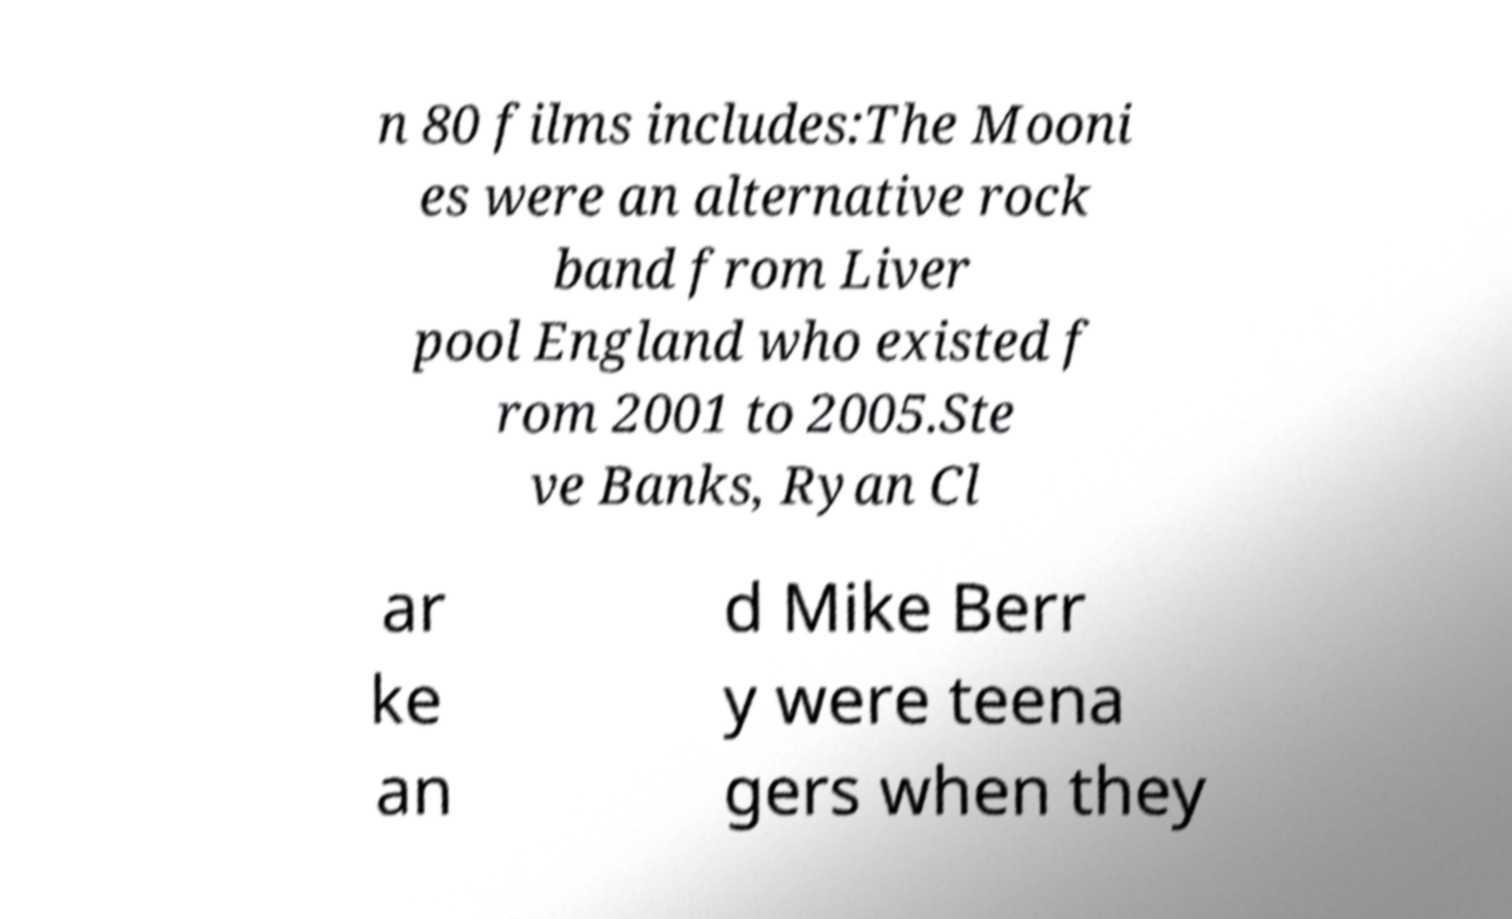There's text embedded in this image that I need extracted. Can you transcribe it verbatim? n 80 films includes:The Mooni es were an alternative rock band from Liver pool England who existed f rom 2001 to 2005.Ste ve Banks, Ryan Cl ar ke an d Mike Berr y were teena gers when they 